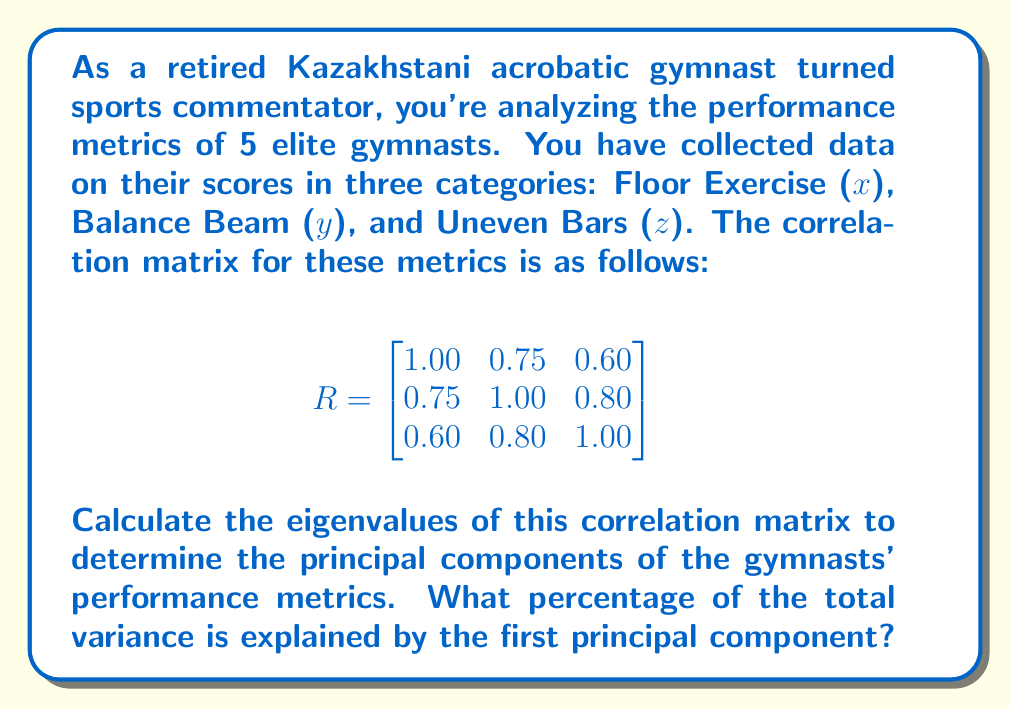What is the answer to this math problem? To calculate the principal components and the variance explained, we need to follow these steps:

1) First, we need to find the eigenvalues of the correlation matrix. The characteristic equation is:

   $$\det(R - \lambda I) = 0$$

2) Expanding this determinant:

   $$\begin{vmatrix}
   1 - \lambda & 0.75 & 0.60 \\
   0.75 & 1 - \lambda & 0.80 \\
   0.60 & 0.80 & 1 - \lambda
   \end{vmatrix} = 0$$

3) This expands to the cubic equation:

   $$-\lambda^3 + 3\lambda^2 - 0.715\lambda - 0.4975 = 0$$

4) Solving this equation (using a calculator or computer algebra system) gives us the eigenvalues:

   $$\lambda_1 \approx 2.5457, \lambda_2 \approx 0.3636, \lambda_3 \approx 0.0907$$

5) The total variance is the sum of the eigenvalues:

   $$2.5457 + 0.3636 + 0.0907 = 3$$

   This is always equal to the number of variables for a correlation matrix.

6) The proportion of variance explained by the first principal component is:

   $$\frac{\lambda_1}{\text{Total Variance}} = \frac{2.5457}{3} \approx 0.8486$$

7) To express this as a percentage, we multiply by 100:

   $$0.8486 * 100 \approx 84.86\%$$

Therefore, the first principal component explains approximately 84.86% of the total variance in the gymnasts' performance metrics.
Answer: 84.86% 